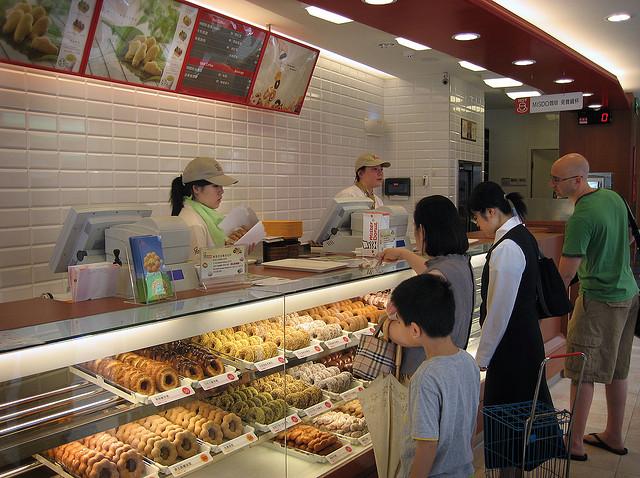What is on display in the case?
Write a very short answer. Pastries. Where is this?
Short answer required. Bakery. What color is the bold man's shirt?
Concise answer only. Green. How many workers are there?
Keep it brief. 2. Must the attendees pay for the food before eating it?
Answer briefly. Yes. Does this appear to be a butcher shop?
Concise answer only. No. What is on the doughnuts to the left of photo?
Keep it brief. Sugar. What color are the trays?
Concise answer only. White. Are these pastries popular based on the amount shown?
Give a very brief answer. Yes. 